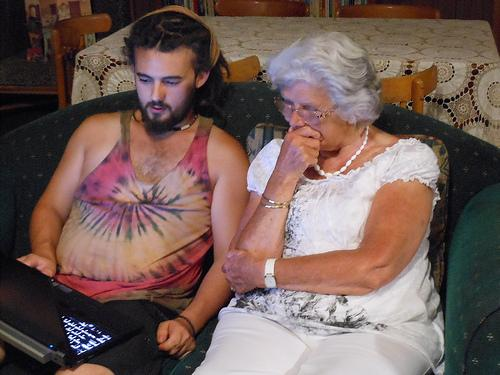Describe the environment in which the man and woman are sitting. The man and woman are sitting on a green couch in a living room with a table next to them with a white tablecloth and a brown wooden chair nearby. How many prominent objects are there in the image, including people and accessories? There are 39 prominent objects in the image, including people, their clothing, and various accessories they are wearing or interacting with. How would you describe the woman's appearance in this image? The woman has white hair, she is wearing eyeglasses, a white top, a beaded necklace, and gold bracelets as accessories. How would the sentiment of the image be evaluated in terms of the tasks listed? An image sentiment analysis task can be used to evaluate the emotions conveyed by the facial expressions, gestures, or the overall setting in the image. List the objects that both the man and woman are interacting with. The man is using a laptop computer with a lit-up keyboard, while the woman is holding her hand to her mouth. What kind of shirt is the man wearing, and what's the color and style of his shirt? The man is wearing a tie-dyed sleeveless shirt with various colors and patterns. What kind of analysis would you use to determine the relationship between the man and woman in this image? Object interaction analysis or complex reasoning task would be appropriate to determine the relationship between the man and woman. What is the primary color of the couch both people are sitting on? The couch they are sitting on is primarily green. 1. Can you find the man wearing a blue hoodie? No, it's not mentioned in the image. 